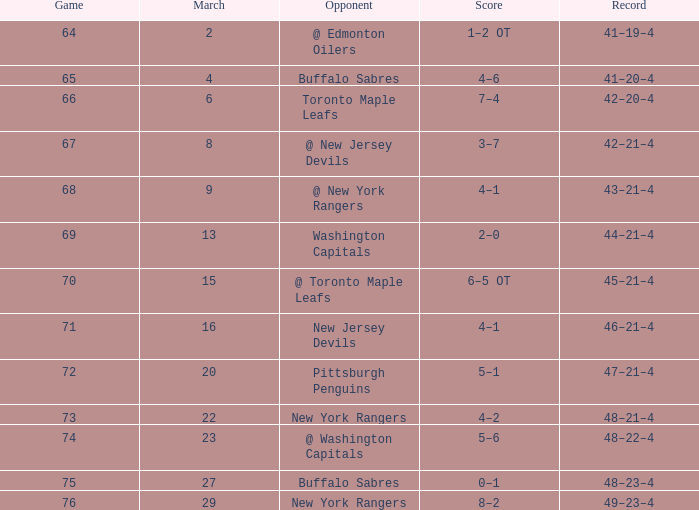Which Score has a March larger than 15, and Points larger than 96, and a Game smaller than 76, and an Opponent of @ washington capitals? 5–6. 